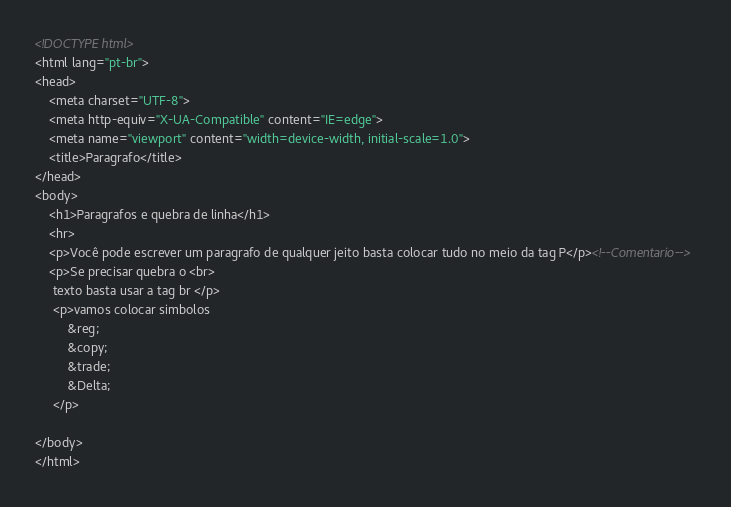Convert code to text. <code><loc_0><loc_0><loc_500><loc_500><_HTML_><!DOCTYPE html>
<html lang="pt-br">
<head>
    <meta charset="UTF-8">
    <meta http-equiv="X-UA-Compatible" content="IE=edge">
    <meta name="viewport" content="width=device-width, initial-scale=1.0">
    <title>Paragrafo</title>
</head>
<body>
    <h1>Paragrafos e quebra de linha</h1>
    <hr>
    <p>Você pode escrever um paragrafo de qualquer jeito basta colocar tudo no meio da tag P</p><!--Comentario-->
    <p>Se precisar quebra o <br>
     texto basta usar a tag br </p>
     <p>vamos colocar simbolos
         &reg;
         &copy;
         &trade;
         &Delta;
     </p>
    
</body>
</html></code> 